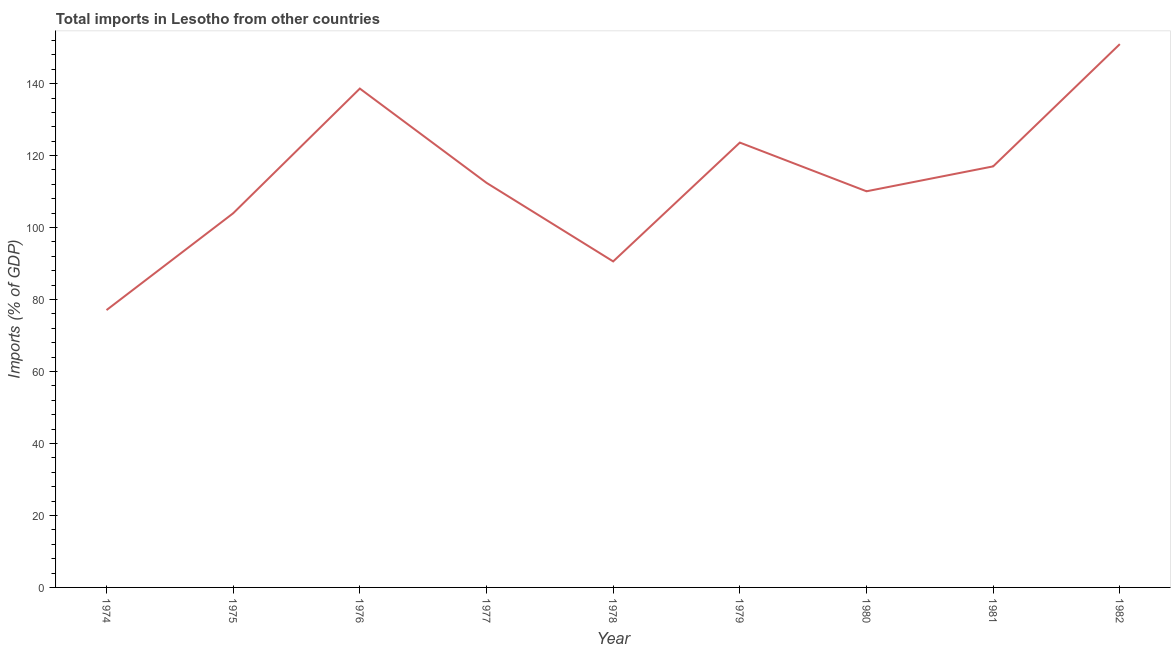What is the total imports in 1979?
Ensure brevity in your answer.  123.62. Across all years, what is the maximum total imports?
Your answer should be very brief. 150.98. Across all years, what is the minimum total imports?
Make the answer very short. 77.07. In which year was the total imports maximum?
Provide a succinct answer. 1982. In which year was the total imports minimum?
Offer a very short reply. 1974. What is the sum of the total imports?
Ensure brevity in your answer.  1024.4. What is the difference between the total imports in 1975 and 1981?
Ensure brevity in your answer.  -13.03. What is the average total imports per year?
Your response must be concise. 113.82. What is the median total imports?
Keep it short and to the point. 112.43. In how many years, is the total imports greater than 148 %?
Give a very brief answer. 1. Do a majority of the years between 1975 and 1980 (inclusive) have total imports greater than 96 %?
Provide a succinct answer. Yes. What is the ratio of the total imports in 1974 to that in 1979?
Offer a very short reply. 0.62. Is the difference between the total imports in 1976 and 1980 greater than the difference between any two years?
Give a very brief answer. No. What is the difference between the highest and the second highest total imports?
Your answer should be compact. 12.35. Is the sum of the total imports in 1978 and 1981 greater than the maximum total imports across all years?
Ensure brevity in your answer.  Yes. What is the difference between the highest and the lowest total imports?
Keep it short and to the point. 73.91. How many lines are there?
Your response must be concise. 1. Are the values on the major ticks of Y-axis written in scientific E-notation?
Make the answer very short. No. Does the graph contain any zero values?
Provide a succinct answer. No. Does the graph contain grids?
Give a very brief answer. No. What is the title of the graph?
Your answer should be compact. Total imports in Lesotho from other countries. What is the label or title of the Y-axis?
Offer a very short reply. Imports (% of GDP). What is the Imports (% of GDP) of 1974?
Ensure brevity in your answer.  77.07. What is the Imports (% of GDP) in 1975?
Keep it short and to the point. 103.98. What is the Imports (% of GDP) in 1976?
Give a very brief answer. 138.63. What is the Imports (% of GDP) of 1977?
Ensure brevity in your answer.  112.43. What is the Imports (% of GDP) in 1978?
Make the answer very short. 90.6. What is the Imports (% of GDP) in 1979?
Give a very brief answer. 123.62. What is the Imports (% of GDP) of 1980?
Make the answer very short. 110.09. What is the Imports (% of GDP) of 1981?
Offer a terse response. 117.01. What is the Imports (% of GDP) in 1982?
Your answer should be very brief. 150.98. What is the difference between the Imports (% of GDP) in 1974 and 1975?
Give a very brief answer. -26.91. What is the difference between the Imports (% of GDP) in 1974 and 1976?
Provide a succinct answer. -61.56. What is the difference between the Imports (% of GDP) in 1974 and 1977?
Offer a terse response. -35.36. What is the difference between the Imports (% of GDP) in 1974 and 1978?
Provide a succinct answer. -13.52. What is the difference between the Imports (% of GDP) in 1974 and 1979?
Give a very brief answer. -46.55. What is the difference between the Imports (% of GDP) in 1974 and 1980?
Ensure brevity in your answer.  -33.01. What is the difference between the Imports (% of GDP) in 1974 and 1981?
Ensure brevity in your answer.  -39.93. What is the difference between the Imports (% of GDP) in 1974 and 1982?
Offer a terse response. -73.91. What is the difference between the Imports (% of GDP) in 1975 and 1976?
Provide a short and direct response. -34.65. What is the difference between the Imports (% of GDP) in 1975 and 1977?
Provide a short and direct response. -8.45. What is the difference between the Imports (% of GDP) in 1975 and 1978?
Make the answer very short. 13.38. What is the difference between the Imports (% of GDP) in 1975 and 1979?
Your response must be concise. -19.64. What is the difference between the Imports (% of GDP) in 1975 and 1980?
Your response must be concise. -6.11. What is the difference between the Imports (% of GDP) in 1975 and 1981?
Provide a short and direct response. -13.03. What is the difference between the Imports (% of GDP) in 1975 and 1982?
Ensure brevity in your answer.  -47. What is the difference between the Imports (% of GDP) in 1976 and 1977?
Keep it short and to the point. 26.2. What is the difference between the Imports (% of GDP) in 1976 and 1978?
Make the answer very short. 48.03. What is the difference between the Imports (% of GDP) in 1976 and 1979?
Your answer should be very brief. 15.01. What is the difference between the Imports (% of GDP) in 1976 and 1980?
Provide a succinct answer. 28.54. What is the difference between the Imports (% of GDP) in 1976 and 1981?
Offer a very short reply. 21.62. What is the difference between the Imports (% of GDP) in 1976 and 1982?
Make the answer very short. -12.35. What is the difference between the Imports (% of GDP) in 1977 and 1978?
Provide a short and direct response. 21.84. What is the difference between the Imports (% of GDP) in 1977 and 1979?
Give a very brief answer. -11.19. What is the difference between the Imports (% of GDP) in 1977 and 1980?
Keep it short and to the point. 2.35. What is the difference between the Imports (% of GDP) in 1977 and 1981?
Your answer should be very brief. -4.57. What is the difference between the Imports (% of GDP) in 1977 and 1982?
Give a very brief answer. -38.55. What is the difference between the Imports (% of GDP) in 1978 and 1979?
Make the answer very short. -33.02. What is the difference between the Imports (% of GDP) in 1978 and 1980?
Provide a succinct answer. -19.49. What is the difference between the Imports (% of GDP) in 1978 and 1981?
Your answer should be very brief. -26.41. What is the difference between the Imports (% of GDP) in 1978 and 1982?
Give a very brief answer. -60.38. What is the difference between the Imports (% of GDP) in 1979 and 1980?
Provide a short and direct response. 13.53. What is the difference between the Imports (% of GDP) in 1979 and 1981?
Provide a succinct answer. 6.61. What is the difference between the Imports (% of GDP) in 1979 and 1982?
Make the answer very short. -27.36. What is the difference between the Imports (% of GDP) in 1980 and 1981?
Offer a very short reply. -6.92. What is the difference between the Imports (% of GDP) in 1980 and 1982?
Offer a very short reply. -40.89. What is the difference between the Imports (% of GDP) in 1981 and 1982?
Keep it short and to the point. -33.97. What is the ratio of the Imports (% of GDP) in 1974 to that in 1975?
Your answer should be very brief. 0.74. What is the ratio of the Imports (% of GDP) in 1974 to that in 1976?
Make the answer very short. 0.56. What is the ratio of the Imports (% of GDP) in 1974 to that in 1977?
Keep it short and to the point. 0.69. What is the ratio of the Imports (% of GDP) in 1974 to that in 1978?
Offer a very short reply. 0.85. What is the ratio of the Imports (% of GDP) in 1974 to that in 1979?
Offer a very short reply. 0.62. What is the ratio of the Imports (% of GDP) in 1974 to that in 1980?
Your answer should be very brief. 0.7. What is the ratio of the Imports (% of GDP) in 1974 to that in 1981?
Make the answer very short. 0.66. What is the ratio of the Imports (% of GDP) in 1974 to that in 1982?
Keep it short and to the point. 0.51. What is the ratio of the Imports (% of GDP) in 1975 to that in 1976?
Provide a short and direct response. 0.75. What is the ratio of the Imports (% of GDP) in 1975 to that in 1977?
Your response must be concise. 0.93. What is the ratio of the Imports (% of GDP) in 1975 to that in 1978?
Your answer should be compact. 1.15. What is the ratio of the Imports (% of GDP) in 1975 to that in 1979?
Offer a very short reply. 0.84. What is the ratio of the Imports (% of GDP) in 1975 to that in 1980?
Give a very brief answer. 0.94. What is the ratio of the Imports (% of GDP) in 1975 to that in 1981?
Provide a short and direct response. 0.89. What is the ratio of the Imports (% of GDP) in 1975 to that in 1982?
Give a very brief answer. 0.69. What is the ratio of the Imports (% of GDP) in 1976 to that in 1977?
Your answer should be very brief. 1.23. What is the ratio of the Imports (% of GDP) in 1976 to that in 1978?
Keep it short and to the point. 1.53. What is the ratio of the Imports (% of GDP) in 1976 to that in 1979?
Your answer should be very brief. 1.12. What is the ratio of the Imports (% of GDP) in 1976 to that in 1980?
Give a very brief answer. 1.26. What is the ratio of the Imports (% of GDP) in 1976 to that in 1981?
Provide a short and direct response. 1.19. What is the ratio of the Imports (% of GDP) in 1976 to that in 1982?
Ensure brevity in your answer.  0.92. What is the ratio of the Imports (% of GDP) in 1977 to that in 1978?
Give a very brief answer. 1.24. What is the ratio of the Imports (% of GDP) in 1977 to that in 1979?
Ensure brevity in your answer.  0.91. What is the ratio of the Imports (% of GDP) in 1977 to that in 1982?
Your answer should be very brief. 0.74. What is the ratio of the Imports (% of GDP) in 1978 to that in 1979?
Your response must be concise. 0.73. What is the ratio of the Imports (% of GDP) in 1978 to that in 1980?
Offer a very short reply. 0.82. What is the ratio of the Imports (% of GDP) in 1978 to that in 1981?
Ensure brevity in your answer.  0.77. What is the ratio of the Imports (% of GDP) in 1978 to that in 1982?
Your response must be concise. 0.6. What is the ratio of the Imports (% of GDP) in 1979 to that in 1980?
Give a very brief answer. 1.12. What is the ratio of the Imports (% of GDP) in 1979 to that in 1981?
Your answer should be compact. 1.06. What is the ratio of the Imports (% of GDP) in 1979 to that in 1982?
Offer a very short reply. 0.82. What is the ratio of the Imports (% of GDP) in 1980 to that in 1981?
Give a very brief answer. 0.94. What is the ratio of the Imports (% of GDP) in 1980 to that in 1982?
Your answer should be compact. 0.73. What is the ratio of the Imports (% of GDP) in 1981 to that in 1982?
Ensure brevity in your answer.  0.78. 